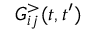Convert formula to latex. <formula><loc_0><loc_0><loc_500><loc_500>G _ { i j } ^ { > } ( t , t ^ { \prime } )</formula> 